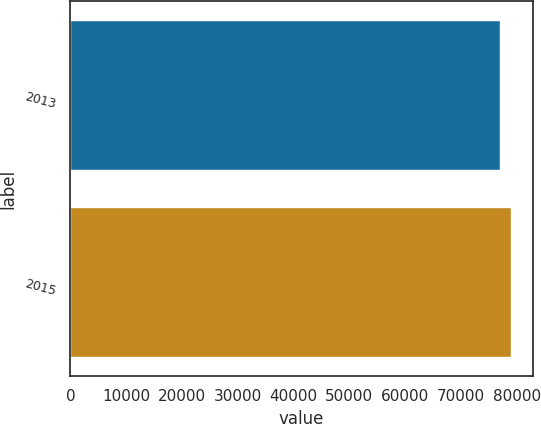Convert chart to OTSL. <chart><loc_0><loc_0><loc_500><loc_500><bar_chart><fcel>2013<fcel>2015<nl><fcel>77037<fcel>78947<nl></chart> 